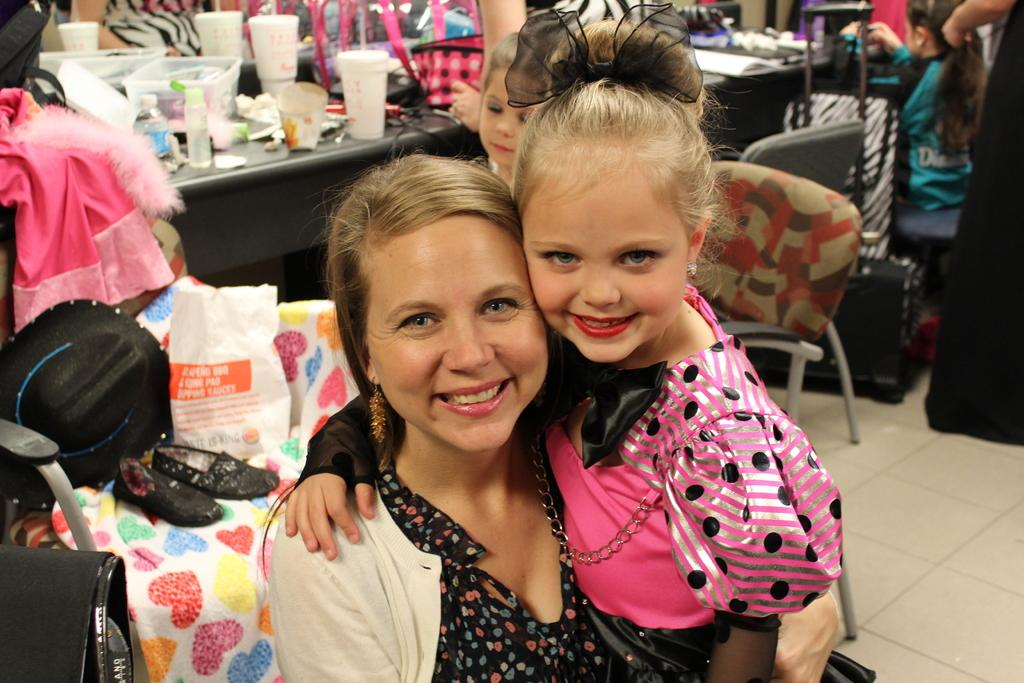How many people are in the room? There are people in the room, but the exact number is not specified in the facts. What is on one of the chairs in the room? There is a hat and footwear on one of the chairs. What can be found on the table in the room? There are bottles, cups, and other objects on the table. Is there a reflective surface in the room? Yes, there is a mirror in the room. What type of book is on the table in the image? There is no book present on the table in the image. How much beef is visible in the image? There is no beef present in the image. 